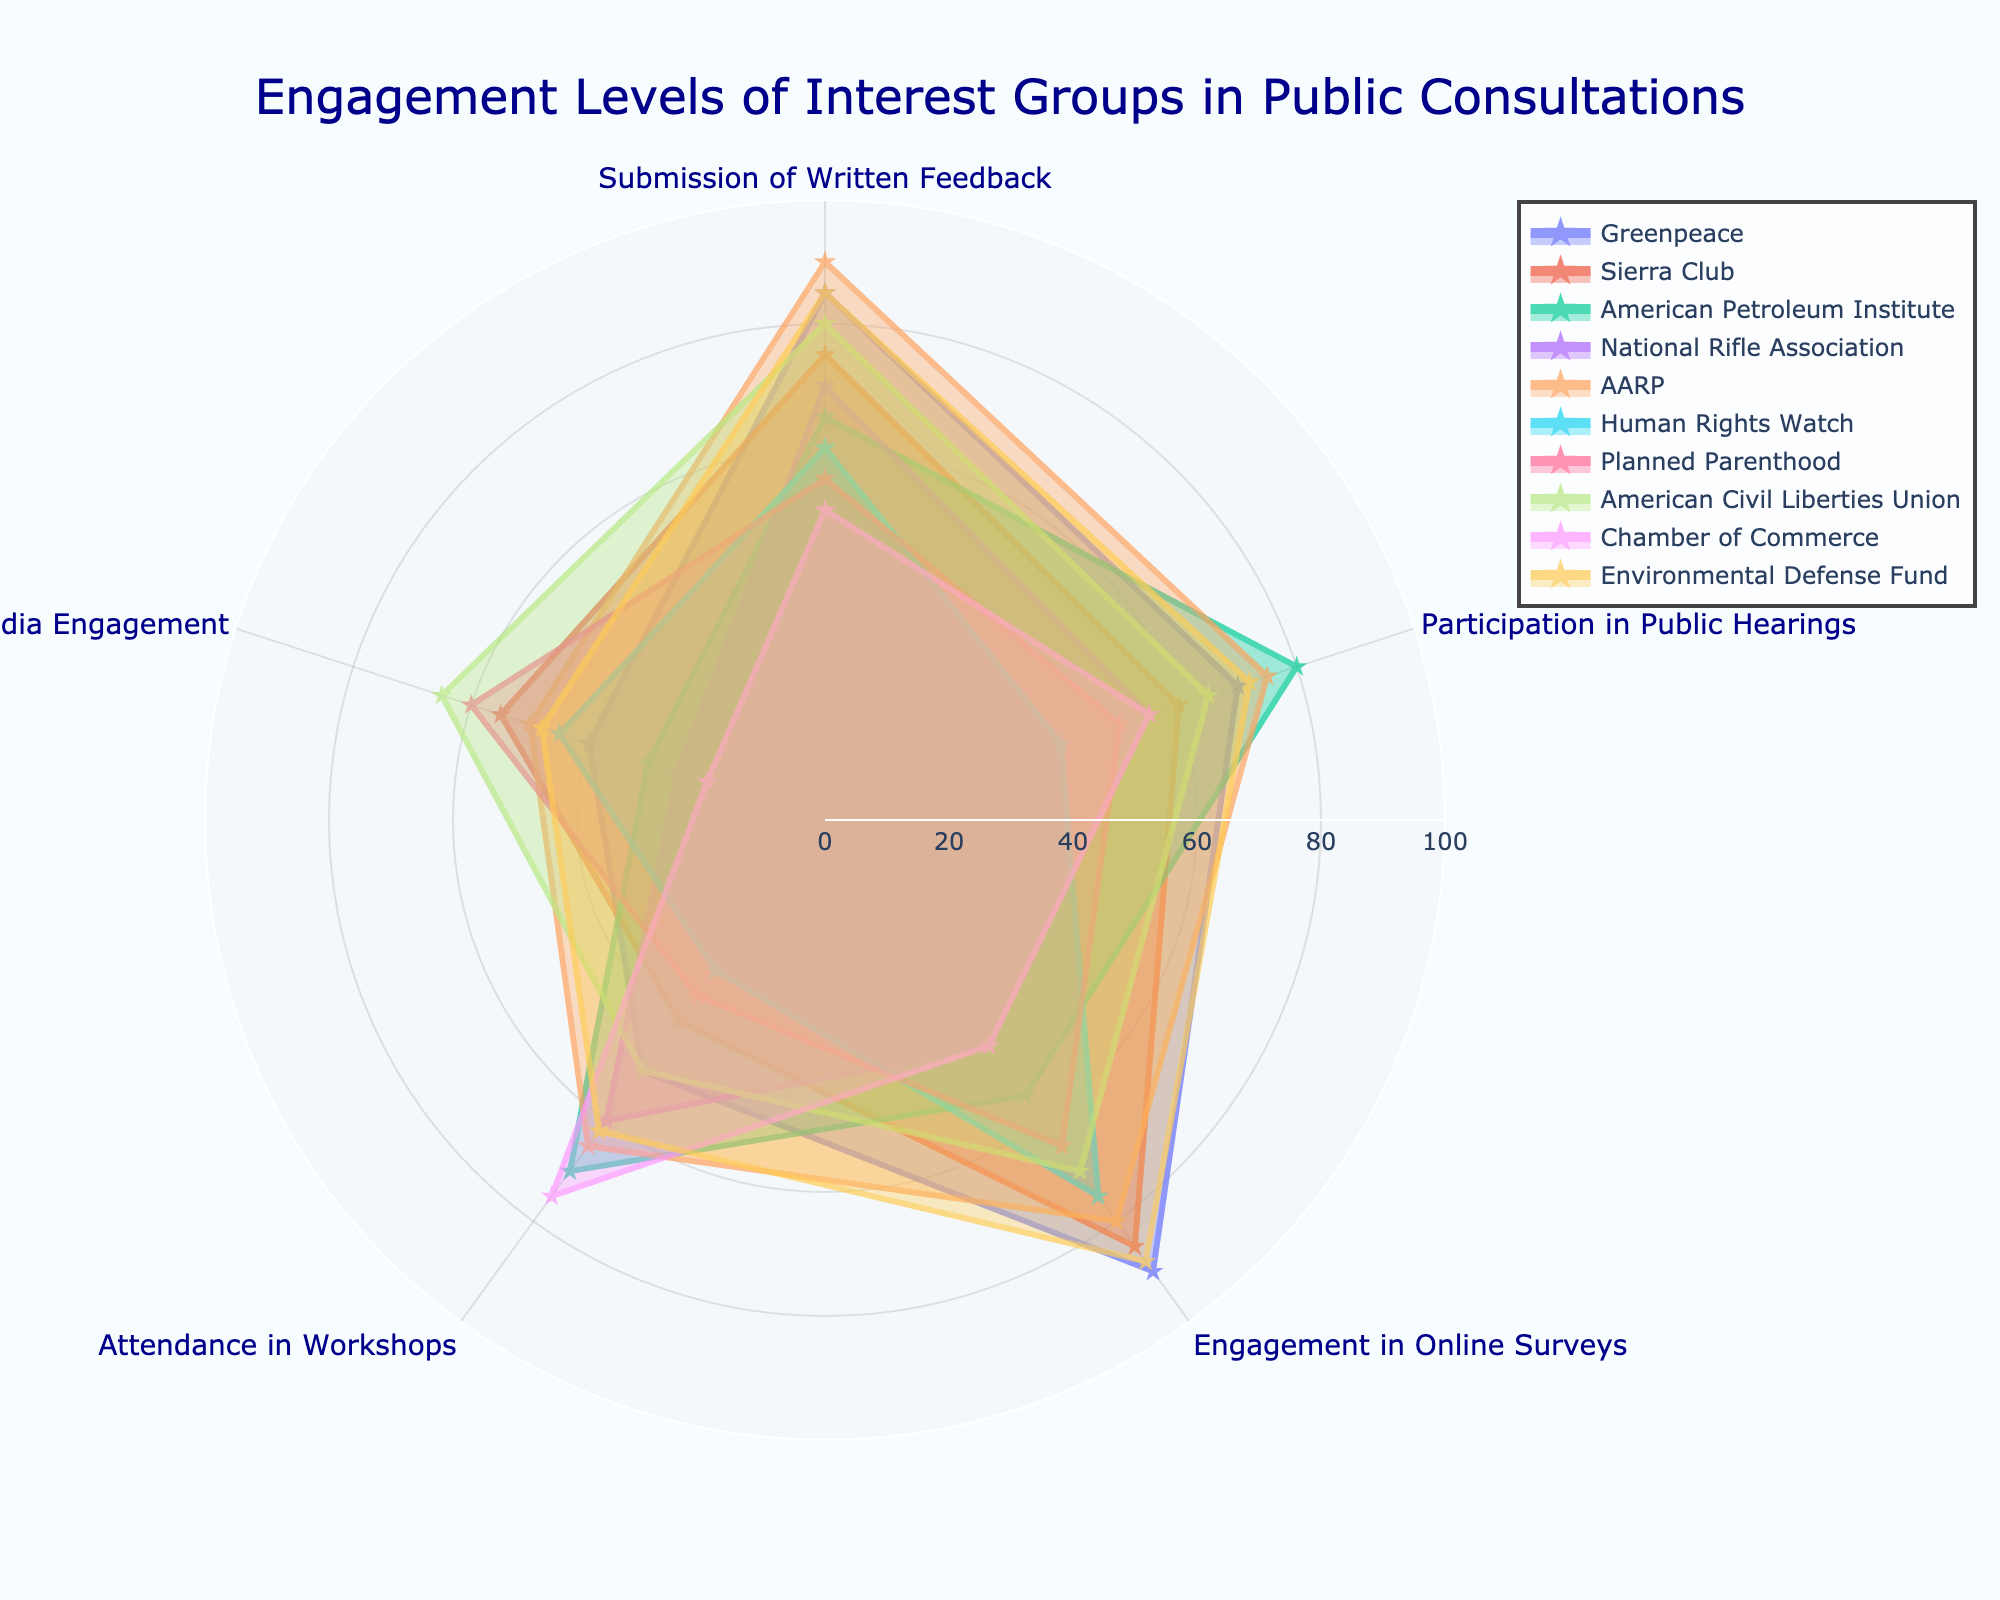What is the overall title of the radar chart? The title can be found at the top of the chart. It provides an overview of what the radar chart intends to convey.
Answer: "Engagement Levels of Interest Groups in Public Consultations" Which interest group has the highest engagement in Online Surveys? Look at the point for 'Engagement in Online Surveys' for each group and compare the values.
Answer: Greenpeace What's the range of values on the radial axis? The radial axis shows the scale for the values. By observing the axis labels, you can see the start and end points.
Answer: 0 to 100 Comparing 'Greenpeace' and 'National Rifle Association', which engagement mode shows the biggest difference between the two groups? Calculate the differences for each engagement mode for the two groups, then identify the largest difference. For example:
Greenpeace vs National Rifle Association 
- Submission of Written Feedback: 85 - 70 = 15
- Participation in Public Hearings: 70 - 55 = 15
- Engagement in Online Surveys: 90 - 45 = 45
- Attendance in Workshops: 50 - 60 = -10
- Social Media Engagement: 40 - 25 = 15
Answer: Engagement in Online Surveys What's the average "Submission of Written Feedback" across all interest groups? Sum all values under the 'Submission of Written Feedback' and divide by the number of interest groups.
(85 + 75 + 65 + 70 + 90 + 60 + 55 + 80 + 50 + 85) = 715
715 / 10 = 71.5
Answer: 71.5 Which interest group has the lowest engagement in "Social Media Engagement"? Locate the values of “Social Media Engagement” for all groups and identify the lowest one.
Answer: Chamber of Commerce What is the median "Attendance in Workshops" among all the groups? Sort the values under 'Attendance in Workshops' and find the middle value.
Values: [30, 35, 40, 50, 50, 60, 62, 65, 70, 75]
Median: (50+60)/2 = 55
Answer: 55 How many engagement modes does 'Sierra Club' have higher values than the 'Chamber of Commerce'? Compare each engagement mode one by one for Sierra Club and Chamber of Commerce:
- Submission of Written Feedback: 75 > 50
- Participation in Public Hearings: 60 > 55
- Engagement in Online Surveys: 85 > 45
- Attendance in Workshops: 40 < 75
- Social Media Engagement: 55 > 20
Sierra Club has higher values in 4 out of 5 modes.
Answer: 4 What visual elements are used to distinguish different interest groups in the radar chart? Notice the visual cues like line types, markers, colors, and labels which are used to differentiate the groups.
Answer: Line patterns, marker shapes (stars), labels, and opacity levels 